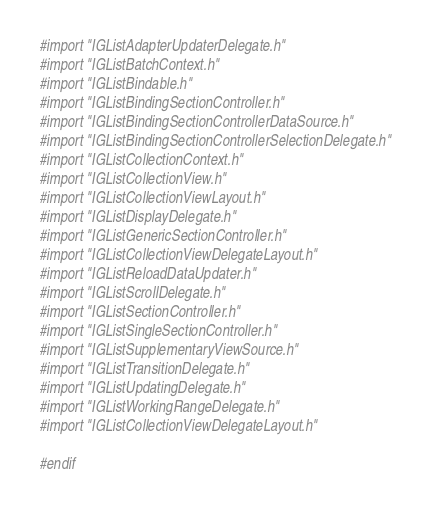Convert code to text. <code><loc_0><loc_0><loc_500><loc_500><_C_>#import "IGListAdapterUpdaterDelegate.h"
#import "IGListBatchContext.h"
#import "IGListBindable.h"
#import "IGListBindingSectionController.h"
#import "IGListBindingSectionControllerDataSource.h"
#import "IGListBindingSectionControllerSelectionDelegate.h"
#import "IGListCollectionContext.h"
#import "IGListCollectionView.h"
#import "IGListCollectionViewLayout.h"
#import "IGListDisplayDelegate.h"
#import "IGListGenericSectionController.h"
#import "IGListCollectionViewDelegateLayout.h"
#import "IGListReloadDataUpdater.h"
#import "IGListScrollDelegate.h"
#import "IGListSectionController.h"
#import "IGListSingleSectionController.h"
#import "IGListSupplementaryViewSource.h"
#import "IGListTransitionDelegate.h"
#import "IGListUpdatingDelegate.h"
#import "IGListWorkingRangeDelegate.h"
#import "IGListCollectionViewDelegateLayout.h"

#endif
</code> 